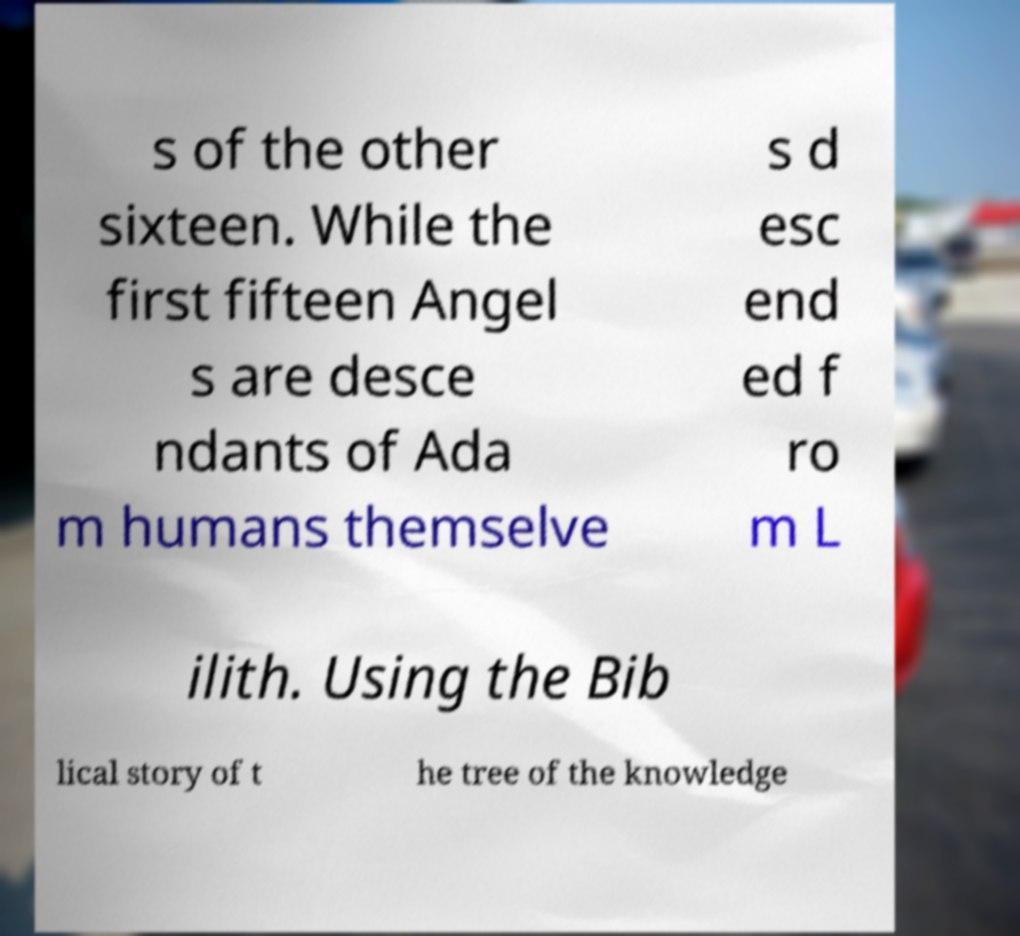Please identify and transcribe the text found in this image. s of the other sixteen. While the first fifteen Angel s are desce ndants of Ada m humans themselve s d esc end ed f ro m L ilith. Using the Bib lical story of t he tree of the knowledge 